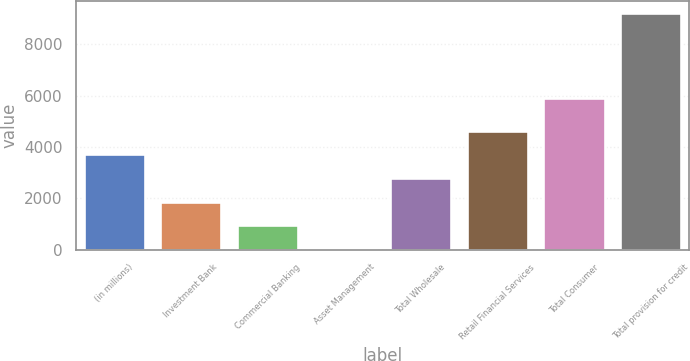Convert chart to OTSL. <chart><loc_0><loc_0><loc_500><loc_500><bar_chart><fcel>(in millions)<fcel>Investment Bank<fcel>Commercial Banking<fcel>Asset Management<fcel>Total Wholesale<fcel>Retail Financial Services<fcel>Total Consumer<fcel>Total provision for credit<nl><fcel>3708.4<fcel>1863.2<fcel>940.6<fcel>18<fcel>2785.8<fcel>4631<fcel>5930<fcel>9244<nl></chart> 